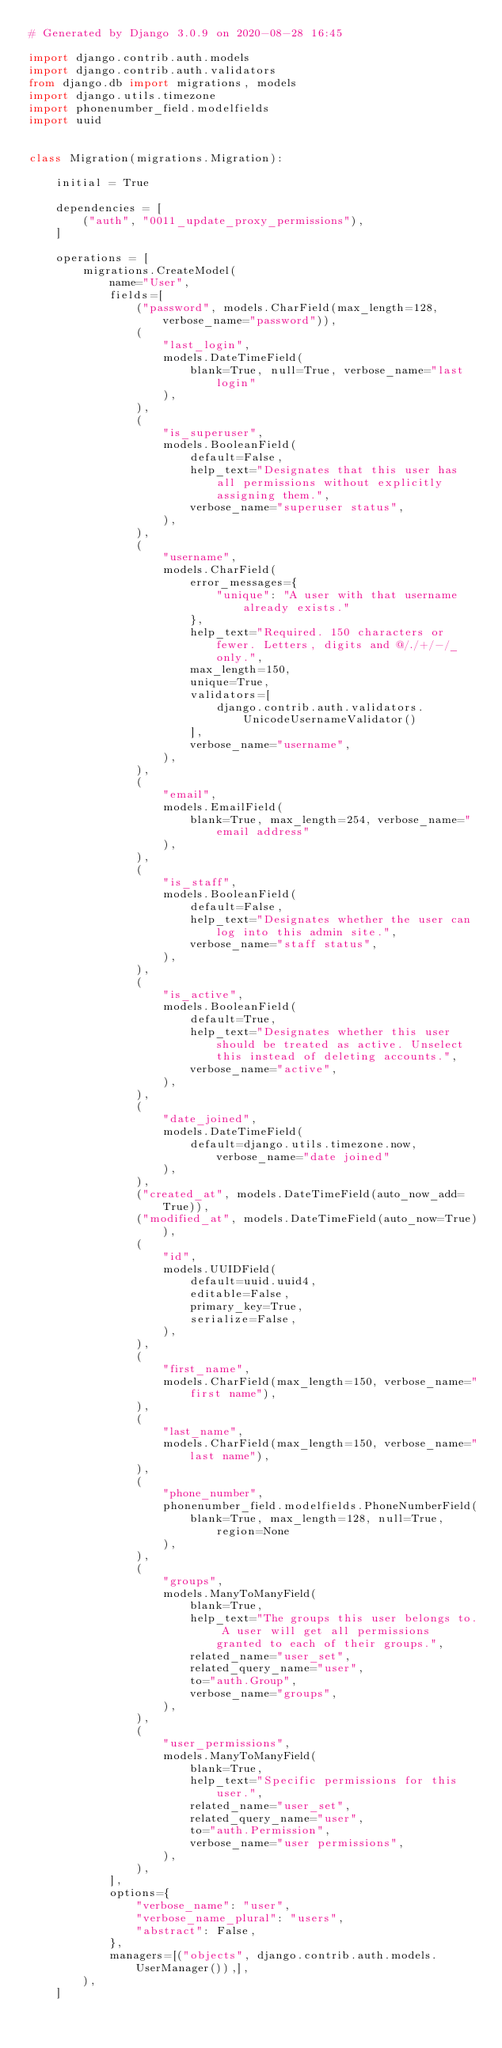<code> <loc_0><loc_0><loc_500><loc_500><_Python_># Generated by Django 3.0.9 on 2020-08-28 16:45

import django.contrib.auth.models
import django.contrib.auth.validators
from django.db import migrations, models
import django.utils.timezone
import phonenumber_field.modelfields
import uuid


class Migration(migrations.Migration):

    initial = True

    dependencies = [
        ("auth", "0011_update_proxy_permissions"),
    ]

    operations = [
        migrations.CreateModel(
            name="User",
            fields=[
                ("password", models.CharField(max_length=128, verbose_name="password")),
                (
                    "last_login",
                    models.DateTimeField(
                        blank=True, null=True, verbose_name="last login"
                    ),
                ),
                (
                    "is_superuser",
                    models.BooleanField(
                        default=False,
                        help_text="Designates that this user has all permissions without explicitly assigning them.",
                        verbose_name="superuser status",
                    ),
                ),
                (
                    "username",
                    models.CharField(
                        error_messages={
                            "unique": "A user with that username already exists."
                        },
                        help_text="Required. 150 characters or fewer. Letters, digits and @/./+/-/_ only.",
                        max_length=150,
                        unique=True,
                        validators=[
                            django.contrib.auth.validators.UnicodeUsernameValidator()
                        ],
                        verbose_name="username",
                    ),
                ),
                (
                    "email",
                    models.EmailField(
                        blank=True, max_length=254, verbose_name="email address"
                    ),
                ),
                (
                    "is_staff",
                    models.BooleanField(
                        default=False,
                        help_text="Designates whether the user can log into this admin site.",
                        verbose_name="staff status",
                    ),
                ),
                (
                    "is_active",
                    models.BooleanField(
                        default=True,
                        help_text="Designates whether this user should be treated as active. Unselect this instead of deleting accounts.",
                        verbose_name="active",
                    ),
                ),
                (
                    "date_joined",
                    models.DateTimeField(
                        default=django.utils.timezone.now, verbose_name="date joined"
                    ),
                ),
                ("created_at", models.DateTimeField(auto_now_add=True)),
                ("modified_at", models.DateTimeField(auto_now=True)),
                (
                    "id",
                    models.UUIDField(
                        default=uuid.uuid4,
                        editable=False,
                        primary_key=True,
                        serialize=False,
                    ),
                ),
                (
                    "first_name",
                    models.CharField(max_length=150, verbose_name="first name"),
                ),
                (
                    "last_name",
                    models.CharField(max_length=150, verbose_name="last name"),
                ),
                (
                    "phone_number",
                    phonenumber_field.modelfields.PhoneNumberField(
                        blank=True, max_length=128, null=True, region=None
                    ),
                ),
                (
                    "groups",
                    models.ManyToManyField(
                        blank=True,
                        help_text="The groups this user belongs to. A user will get all permissions granted to each of their groups.",
                        related_name="user_set",
                        related_query_name="user",
                        to="auth.Group",
                        verbose_name="groups",
                    ),
                ),
                (
                    "user_permissions",
                    models.ManyToManyField(
                        blank=True,
                        help_text="Specific permissions for this user.",
                        related_name="user_set",
                        related_query_name="user",
                        to="auth.Permission",
                        verbose_name="user permissions",
                    ),
                ),
            ],
            options={
                "verbose_name": "user",
                "verbose_name_plural": "users",
                "abstract": False,
            },
            managers=[("objects", django.contrib.auth.models.UserManager()),],
        ),
    ]
</code> 